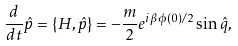Convert formula to latex. <formula><loc_0><loc_0><loc_500><loc_500>\frac { d } { d t } \hat { p } = \{ H , \hat { p } \} = - \frac { m } { 2 } e ^ { i \beta \phi ( 0 ) / 2 } \sin \hat { q } ,</formula> 